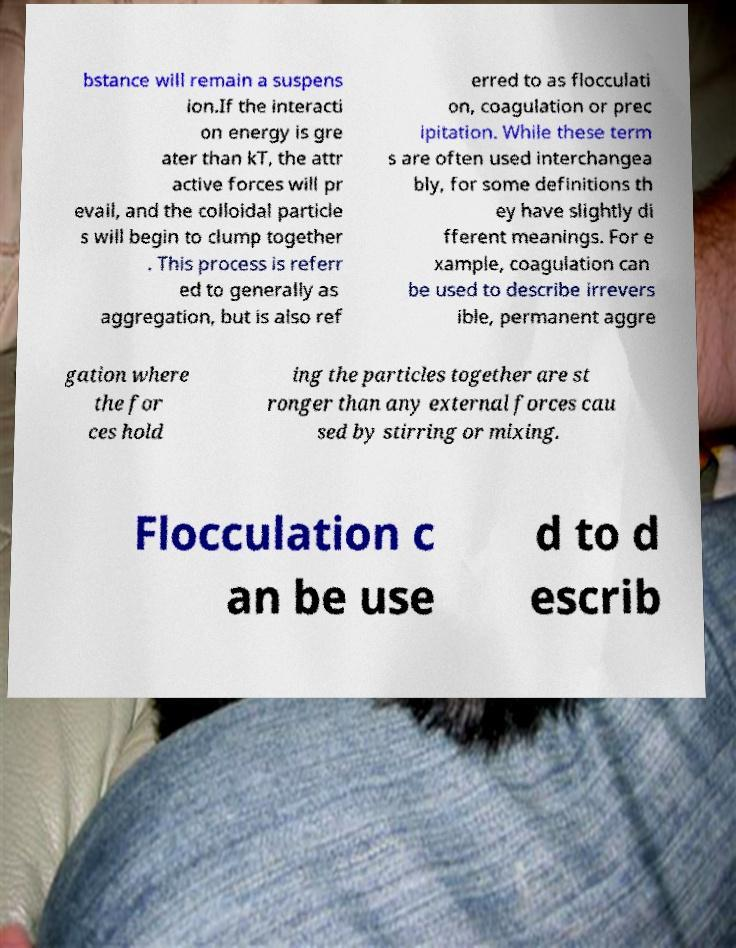Can you read and provide the text displayed in the image?This photo seems to have some interesting text. Can you extract and type it out for me? bstance will remain a suspens ion.If the interacti on energy is gre ater than kT, the attr active forces will pr evail, and the colloidal particle s will begin to clump together . This process is referr ed to generally as aggregation, but is also ref erred to as flocculati on, coagulation or prec ipitation. While these term s are often used interchangea bly, for some definitions th ey have slightly di fferent meanings. For e xample, coagulation can be used to describe irrevers ible, permanent aggre gation where the for ces hold ing the particles together are st ronger than any external forces cau sed by stirring or mixing. Flocculation c an be use d to d escrib 